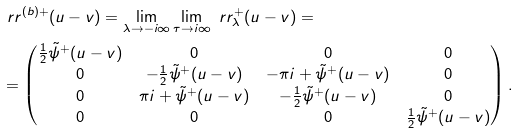Convert formula to latex. <formula><loc_0><loc_0><loc_500><loc_500>& \ r r ^ { ( b ) + } ( u - v ) = \lim _ { \lambda \to - i \infty } \lim _ { \tau \to i \infty } \ r r _ { \lambda } ^ { + } ( u - v ) = \\ & = \begin{pmatrix} \frac { 1 } { 2 } \tilde { \psi } ^ { + } ( u - v ) & 0 & 0 & 0 \\ 0 & - \frac { 1 } { 2 } \tilde { \psi } ^ { + } ( u - v ) & - \pi i + \tilde { \psi } ^ { + } ( u - v ) & 0 \\ 0 & \pi i + \tilde { \psi } ^ { + } ( u - v ) & - \frac { 1 } { 2 } \tilde { \psi } ^ { + } ( u - v ) & 0 \\ 0 & 0 & 0 & \frac { 1 } { 2 } \tilde { \psi } ^ { + } ( u - v ) \end{pmatrix} .</formula> 